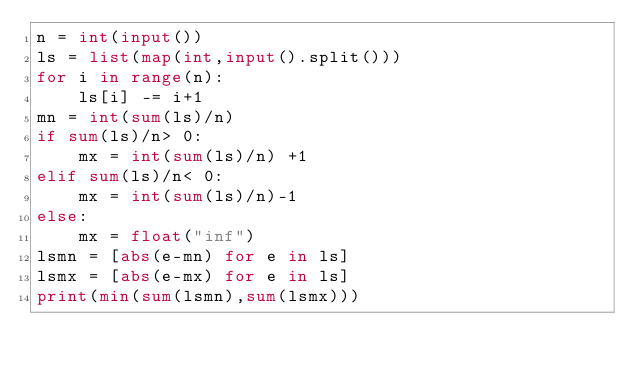<code> <loc_0><loc_0><loc_500><loc_500><_Python_>n = int(input())
ls = list(map(int,input().split()))
for i in range(n):
    ls[i] -= i+1
mn = int(sum(ls)/n)
if sum(ls)/n> 0:
    mx = int(sum(ls)/n) +1
elif sum(ls)/n< 0:
    mx = int(sum(ls)/n)-1
else:
    mx = float("inf")
lsmn = [abs(e-mn) for e in ls]
lsmx = [abs(e-mx) for e in ls]
print(min(sum(lsmn),sum(lsmx)))</code> 